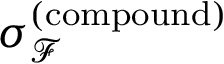Convert formula to latex. <formula><loc_0><loc_0><loc_500><loc_500>\sigma _ { \mathcal { F } } ^ { ( c o m p o u n d ) }</formula> 